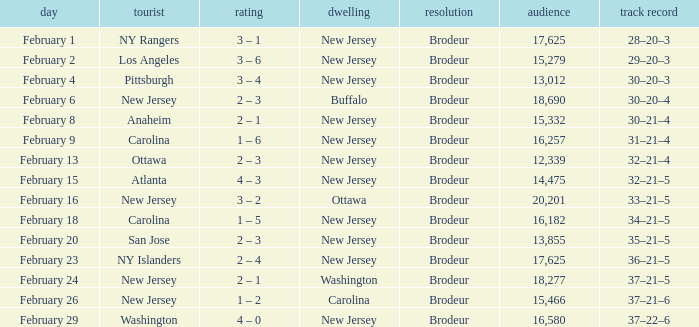What was the record when the visiting team was Ottawa? 32–21–4. 